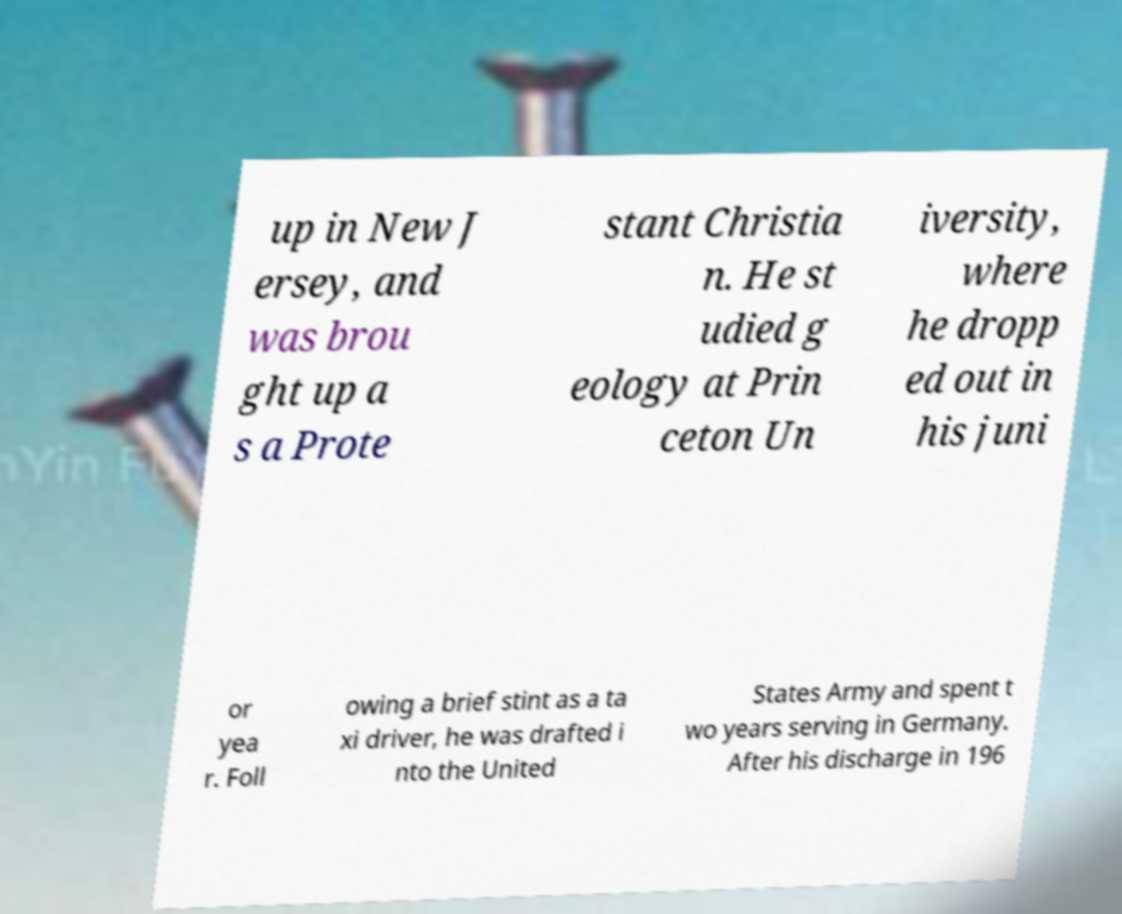For documentation purposes, I need the text within this image transcribed. Could you provide that? up in New J ersey, and was brou ght up a s a Prote stant Christia n. He st udied g eology at Prin ceton Un iversity, where he dropp ed out in his juni or yea r. Foll owing a brief stint as a ta xi driver, he was drafted i nto the United States Army and spent t wo years serving in Germany. After his discharge in 196 